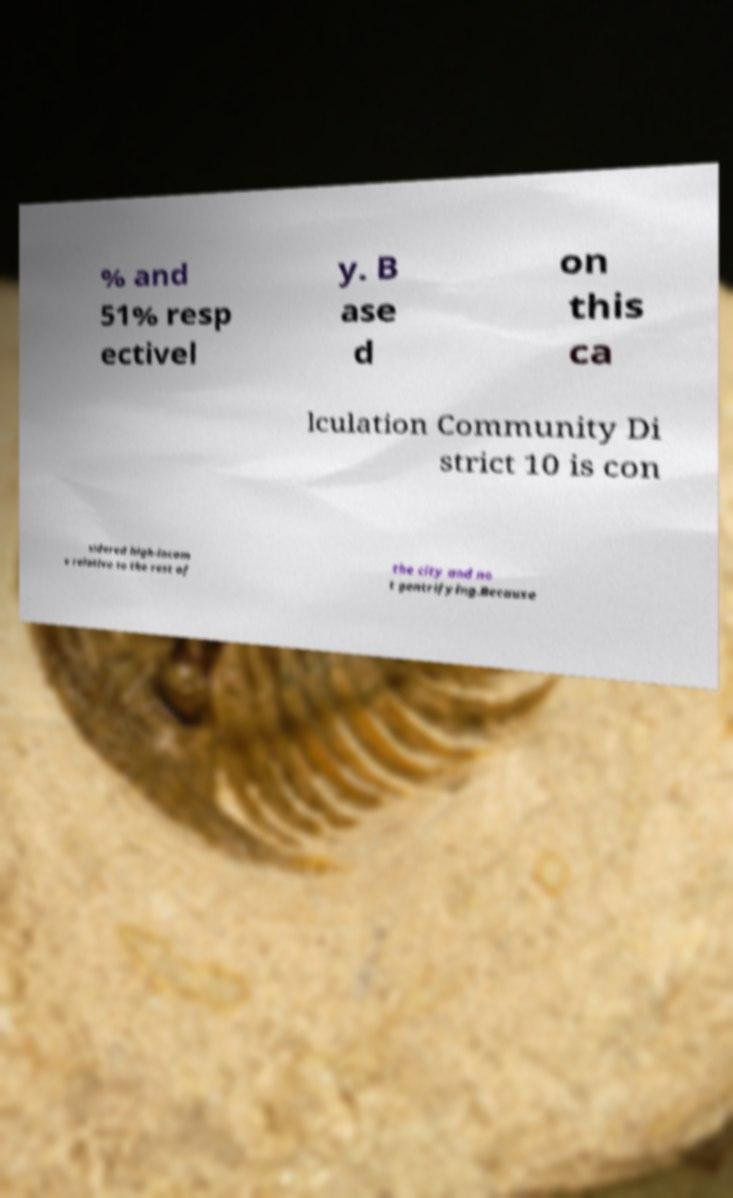Could you assist in decoding the text presented in this image and type it out clearly? % and 51% resp ectivel y. B ase d on this ca lculation Community Di strict 10 is con sidered high-incom e relative to the rest of the city and no t gentrifying.Because 